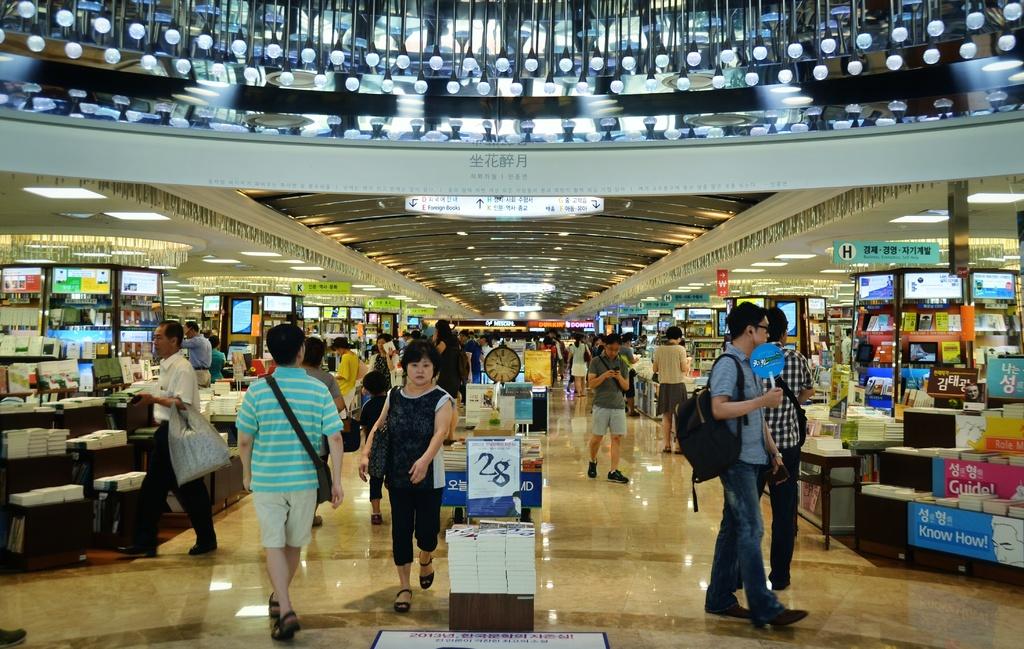What kind of things can you buy in this store?
Offer a terse response. Answering does not require reading text in the image. What is on the blue banner on the bottom right?
Provide a succinct answer. Know how. 